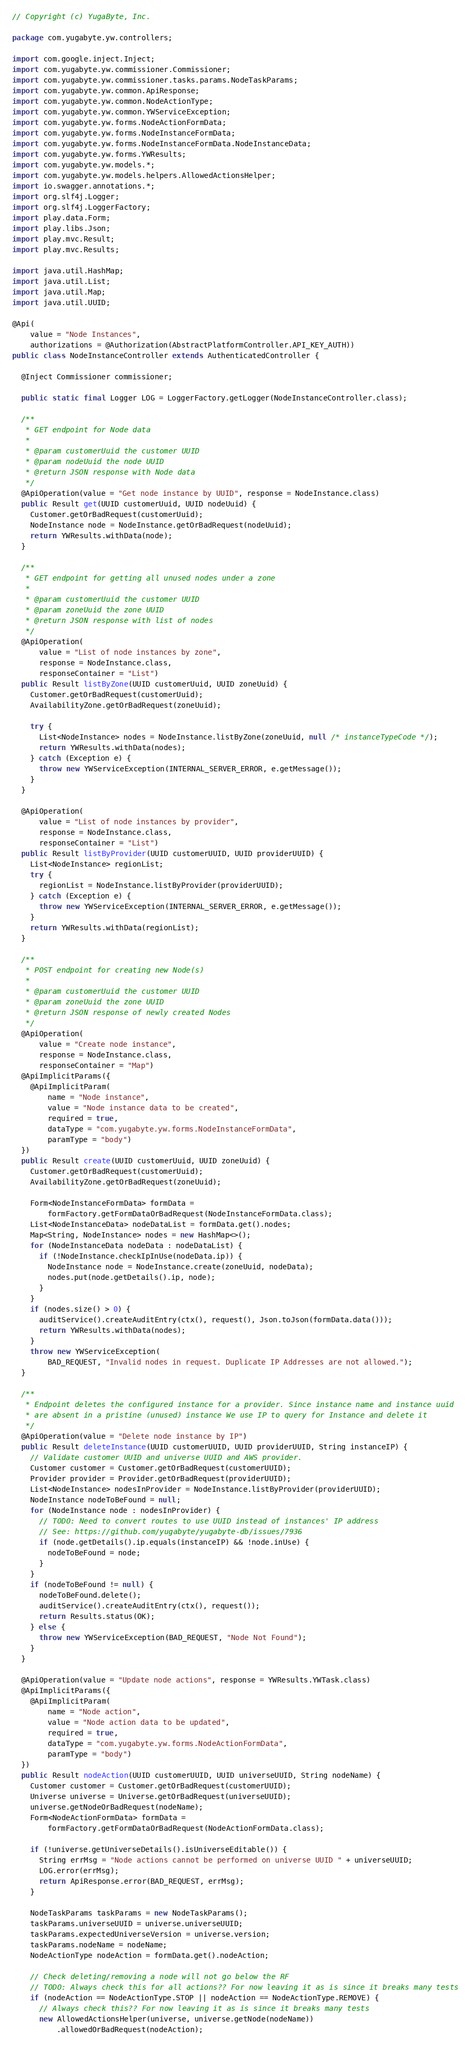<code> <loc_0><loc_0><loc_500><loc_500><_Java_>// Copyright (c) YugaByte, Inc.

package com.yugabyte.yw.controllers;

import com.google.inject.Inject;
import com.yugabyte.yw.commissioner.Commissioner;
import com.yugabyte.yw.commissioner.tasks.params.NodeTaskParams;
import com.yugabyte.yw.common.ApiResponse;
import com.yugabyte.yw.common.NodeActionType;
import com.yugabyte.yw.common.YWServiceException;
import com.yugabyte.yw.forms.NodeActionFormData;
import com.yugabyte.yw.forms.NodeInstanceFormData;
import com.yugabyte.yw.forms.NodeInstanceFormData.NodeInstanceData;
import com.yugabyte.yw.forms.YWResults;
import com.yugabyte.yw.models.*;
import com.yugabyte.yw.models.helpers.AllowedActionsHelper;
import io.swagger.annotations.*;
import org.slf4j.Logger;
import org.slf4j.LoggerFactory;
import play.data.Form;
import play.libs.Json;
import play.mvc.Result;
import play.mvc.Results;

import java.util.HashMap;
import java.util.List;
import java.util.Map;
import java.util.UUID;

@Api(
    value = "Node Instances",
    authorizations = @Authorization(AbstractPlatformController.API_KEY_AUTH))
public class NodeInstanceController extends AuthenticatedController {

  @Inject Commissioner commissioner;

  public static final Logger LOG = LoggerFactory.getLogger(NodeInstanceController.class);

  /**
   * GET endpoint for Node data
   *
   * @param customerUuid the customer UUID
   * @param nodeUuid the node UUID
   * @return JSON response with Node data
   */
  @ApiOperation(value = "Get node instance by UUID", response = NodeInstance.class)
  public Result get(UUID customerUuid, UUID nodeUuid) {
    Customer.getOrBadRequest(customerUuid);
    NodeInstance node = NodeInstance.getOrBadRequest(nodeUuid);
    return YWResults.withData(node);
  }

  /**
   * GET endpoint for getting all unused nodes under a zone
   *
   * @param customerUuid the customer UUID
   * @param zoneUuid the zone UUID
   * @return JSON response with list of nodes
   */
  @ApiOperation(
      value = "List of node instances by zone",
      response = NodeInstance.class,
      responseContainer = "List")
  public Result listByZone(UUID customerUuid, UUID zoneUuid) {
    Customer.getOrBadRequest(customerUuid);
    AvailabilityZone.getOrBadRequest(zoneUuid);

    try {
      List<NodeInstance> nodes = NodeInstance.listByZone(zoneUuid, null /* instanceTypeCode */);
      return YWResults.withData(nodes);
    } catch (Exception e) {
      throw new YWServiceException(INTERNAL_SERVER_ERROR, e.getMessage());
    }
  }

  @ApiOperation(
      value = "List of node instances by provider",
      response = NodeInstance.class,
      responseContainer = "List")
  public Result listByProvider(UUID customerUUID, UUID providerUUID) {
    List<NodeInstance> regionList;
    try {
      regionList = NodeInstance.listByProvider(providerUUID);
    } catch (Exception e) {
      throw new YWServiceException(INTERNAL_SERVER_ERROR, e.getMessage());
    }
    return YWResults.withData(regionList);
  }

  /**
   * POST endpoint for creating new Node(s)
   *
   * @param customerUuid the customer UUID
   * @param zoneUuid the zone UUID
   * @return JSON response of newly created Nodes
   */
  @ApiOperation(
      value = "Create node instance",
      response = NodeInstance.class,
      responseContainer = "Map")
  @ApiImplicitParams({
    @ApiImplicitParam(
        name = "Node instance",
        value = "Node instance data to be created",
        required = true,
        dataType = "com.yugabyte.yw.forms.NodeInstanceFormData",
        paramType = "body")
  })
  public Result create(UUID customerUuid, UUID zoneUuid) {
    Customer.getOrBadRequest(customerUuid);
    AvailabilityZone.getOrBadRequest(zoneUuid);

    Form<NodeInstanceFormData> formData =
        formFactory.getFormDataOrBadRequest(NodeInstanceFormData.class);
    List<NodeInstanceData> nodeDataList = formData.get().nodes;
    Map<String, NodeInstance> nodes = new HashMap<>();
    for (NodeInstanceData nodeData : nodeDataList) {
      if (!NodeInstance.checkIpInUse(nodeData.ip)) {
        NodeInstance node = NodeInstance.create(zoneUuid, nodeData);
        nodes.put(node.getDetails().ip, node);
      }
    }
    if (nodes.size() > 0) {
      auditService().createAuditEntry(ctx(), request(), Json.toJson(formData.data()));
      return YWResults.withData(nodes);
    }
    throw new YWServiceException(
        BAD_REQUEST, "Invalid nodes in request. Duplicate IP Addresses are not allowed.");
  }

  /**
   * Endpoint deletes the configured instance for a provider. Since instance name and instance uuid
   * are absent in a pristine (unused) instance We use IP to query for Instance and delete it
   */
  @ApiOperation(value = "Delete node instance by IP")
  public Result deleteInstance(UUID customerUUID, UUID providerUUID, String instanceIP) {
    // Validate customer UUID and universe UUID and AWS provider.
    Customer customer = Customer.getOrBadRequest(customerUUID);
    Provider provider = Provider.getOrBadRequest(providerUUID);
    List<NodeInstance> nodesInProvider = NodeInstance.listByProvider(providerUUID);
    NodeInstance nodeToBeFound = null;
    for (NodeInstance node : nodesInProvider) {
      // TODO: Need to convert routes to use UUID instead of instances' IP address
      // See: https://github.com/yugabyte/yugabyte-db/issues/7936
      if (node.getDetails().ip.equals(instanceIP) && !node.inUse) {
        nodeToBeFound = node;
      }
    }
    if (nodeToBeFound != null) {
      nodeToBeFound.delete();
      auditService().createAuditEntry(ctx(), request());
      return Results.status(OK);
    } else {
      throw new YWServiceException(BAD_REQUEST, "Node Not Found");
    }
  }

  @ApiOperation(value = "Update node actions", response = YWResults.YWTask.class)
  @ApiImplicitParams({
    @ApiImplicitParam(
        name = "Node action",
        value = "Node action data to be updated",
        required = true,
        dataType = "com.yugabyte.yw.forms.NodeActionFormData",
        paramType = "body")
  })
  public Result nodeAction(UUID customerUUID, UUID universeUUID, String nodeName) {
    Customer customer = Customer.getOrBadRequest(customerUUID);
    Universe universe = Universe.getOrBadRequest(universeUUID);
    universe.getNodeOrBadRequest(nodeName);
    Form<NodeActionFormData> formData =
        formFactory.getFormDataOrBadRequest(NodeActionFormData.class);

    if (!universe.getUniverseDetails().isUniverseEditable()) {
      String errMsg = "Node actions cannot be performed on universe UUID " + universeUUID;
      LOG.error(errMsg);
      return ApiResponse.error(BAD_REQUEST, errMsg);
    }

    NodeTaskParams taskParams = new NodeTaskParams();
    taskParams.universeUUID = universe.universeUUID;
    taskParams.expectedUniverseVersion = universe.version;
    taskParams.nodeName = nodeName;
    NodeActionType nodeAction = formData.get().nodeAction;

    // Check deleting/removing a node will not go below the RF
    // TODO: Always check this for all actions?? For now leaving it as is since it breaks many tests
    if (nodeAction == NodeActionType.STOP || nodeAction == NodeActionType.REMOVE) {
      // Always check this?? For now leaving it as is since it breaks many tests
      new AllowedActionsHelper(universe, universe.getNode(nodeName))
          .allowedOrBadRequest(nodeAction);</code> 